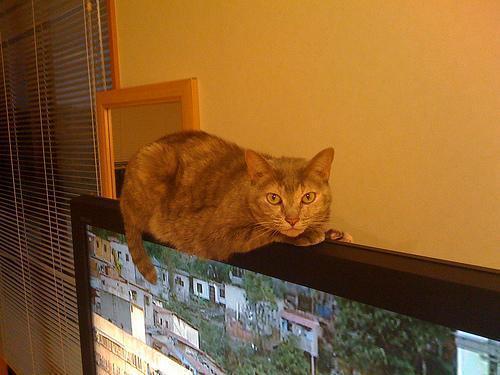How many cats are there?
Give a very brief answer. 1. 